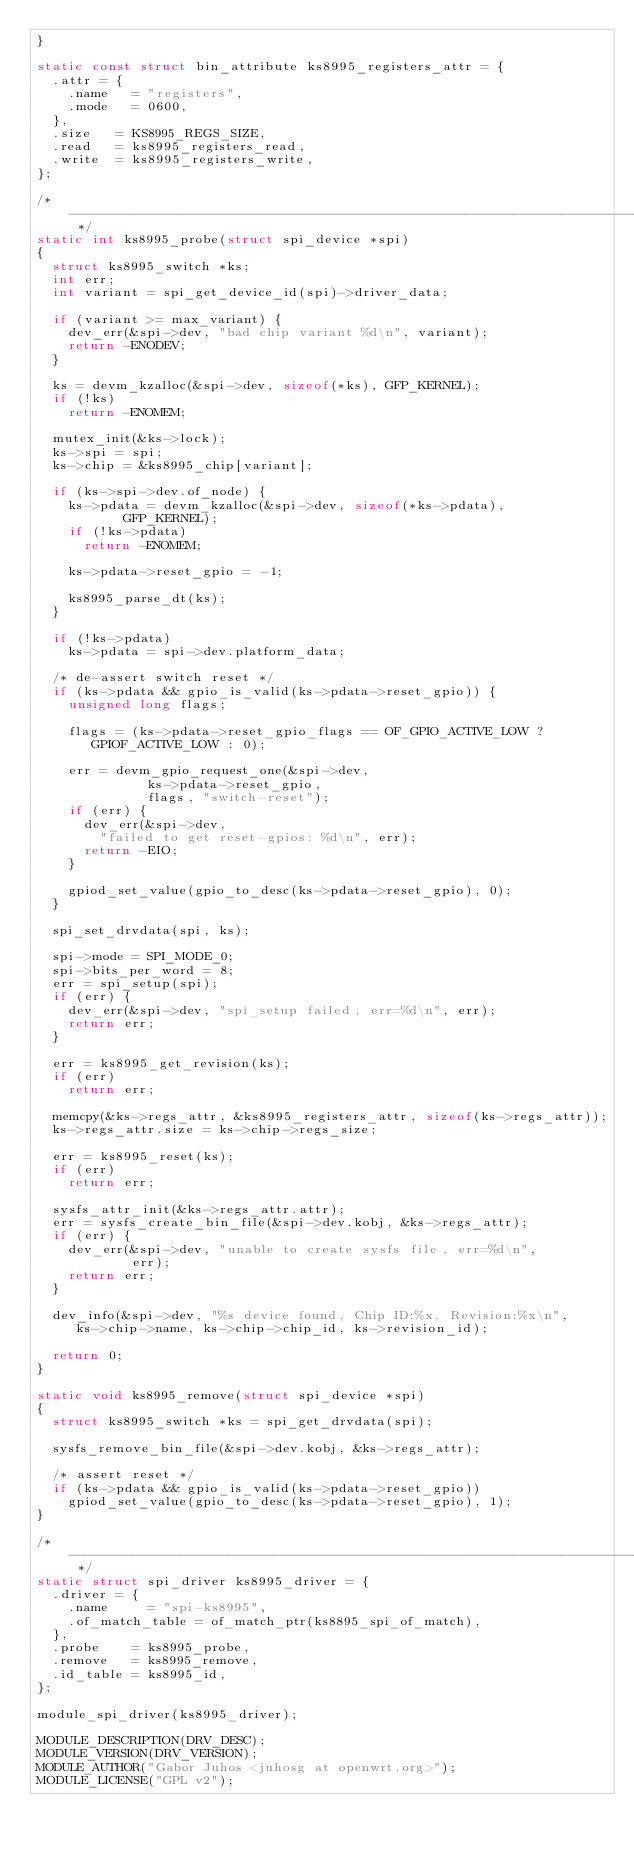Convert code to text. <code><loc_0><loc_0><loc_500><loc_500><_C_>}

static const struct bin_attribute ks8995_registers_attr = {
	.attr = {
		.name   = "registers",
		.mode   = 0600,
	},
	.size   = KS8995_REGS_SIZE,
	.read   = ks8995_registers_read,
	.write  = ks8995_registers_write,
};

/* ------------------------------------------------------------------------ */
static int ks8995_probe(struct spi_device *spi)
{
	struct ks8995_switch *ks;
	int err;
	int variant = spi_get_device_id(spi)->driver_data;

	if (variant >= max_variant) {
		dev_err(&spi->dev, "bad chip variant %d\n", variant);
		return -ENODEV;
	}

	ks = devm_kzalloc(&spi->dev, sizeof(*ks), GFP_KERNEL);
	if (!ks)
		return -ENOMEM;

	mutex_init(&ks->lock);
	ks->spi = spi;
	ks->chip = &ks8995_chip[variant];

	if (ks->spi->dev.of_node) {
		ks->pdata = devm_kzalloc(&spi->dev, sizeof(*ks->pdata),
					 GFP_KERNEL);
		if (!ks->pdata)
			return -ENOMEM;

		ks->pdata->reset_gpio = -1;

		ks8995_parse_dt(ks);
	}

	if (!ks->pdata)
		ks->pdata = spi->dev.platform_data;

	/* de-assert switch reset */
	if (ks->pdata && gpio_is_valid(ks->pdata->reset_gpio)) {
		unsigned long flags;

		flags = (ks->pdata->reset_gpio_flags == OF_GPIO_ACTIVE_LOW ?
			 GPIOF_ACTIVE_LOW : 0);

		err = devm_gpio_request_one(&spi->dev,
					    ks->pdata->reset_gpio,
					    flags, "switch-reset");
		if (err) {
			dev_err(&spi->dev,
				"failed to get reset-gpios: %d\n", err);
			return -EIO;
		}

		gpiod_set_value(gpio_to_desc(ks->pdata->reset_gpio), 0);
	}

	spi_set_drvdata(spi, ks);

	spi->mode = SPI_MODE_0;
	spi->bits_per_word = 8;
	err = spi_setup(spi);
	if (err) {
		dev_err(&spi->dev, "spi_setup failed, err=%d\n", err);
		return err;
	}

	err = ks8995_get_revision(ks);
	if (err)
		return err;

	memcpy(&ks->regs_attr, &ks8995_registers_attr, sizeof(ks->regs_attr));
	ks->regs_attr.size = ks->chip->regs_size;

	err = ks8995_reset(ks);
	if (err)
		return err;

	sysfs_attr_init(&ks->regs_attr.attr);
	err = sysfs_create_bin_file(&spi->dev.kobj, &ks->regs_attr);
	if (err) {
		dev_err(&spi->dev, "unable to create sysfs file, err=%d\n",
				    err);
		return err;
	}

	dev_info(&spi->dev, "%s device found, Chip ID:%x, Revision:%x\n",
		 ks->chip->name, ks->chip->chip_id, ks->revision_id);

	return 0;
}

static void ks8995_remove(struct spi_device *spi)
{
	struct ks8995_switch *ks = spi_get_drvdata(spi);

	sysfs_remove_bin_file(&spi->dev.kobj, &ks->regs_attr);

	/* assert reset */
	if (ks->pdata && gpio_is_valid(ks->pdata->reset_gpio))
		gpiod_set_value(gpio_to_desc(ks->pdata->reset_gpio), 1);
}

/* ------------------------------------------------------------------------ */
static struct spi_driver ks8995_driver = {
	.driver = {
		.name	    = "spi-ks8995",
		.of_match_table = of_match_ptr(ks8895_spi_of_match),
	},
	.probe	  = ks8995_probe,
	.remove	  = ks8995_remove,
	.id_table = ks8995_id,
};

module_spi_driver(ks8995_driver);

MODULE_DESCRIPTION(DRV_DESC);
MODULE_VERSION(DRV_VERSION);
MODULE_AUTHOR("Gabor Juhos <juhosg at openwrt.org>");
MODULE_LICENSE("GPL v2");
</code> 